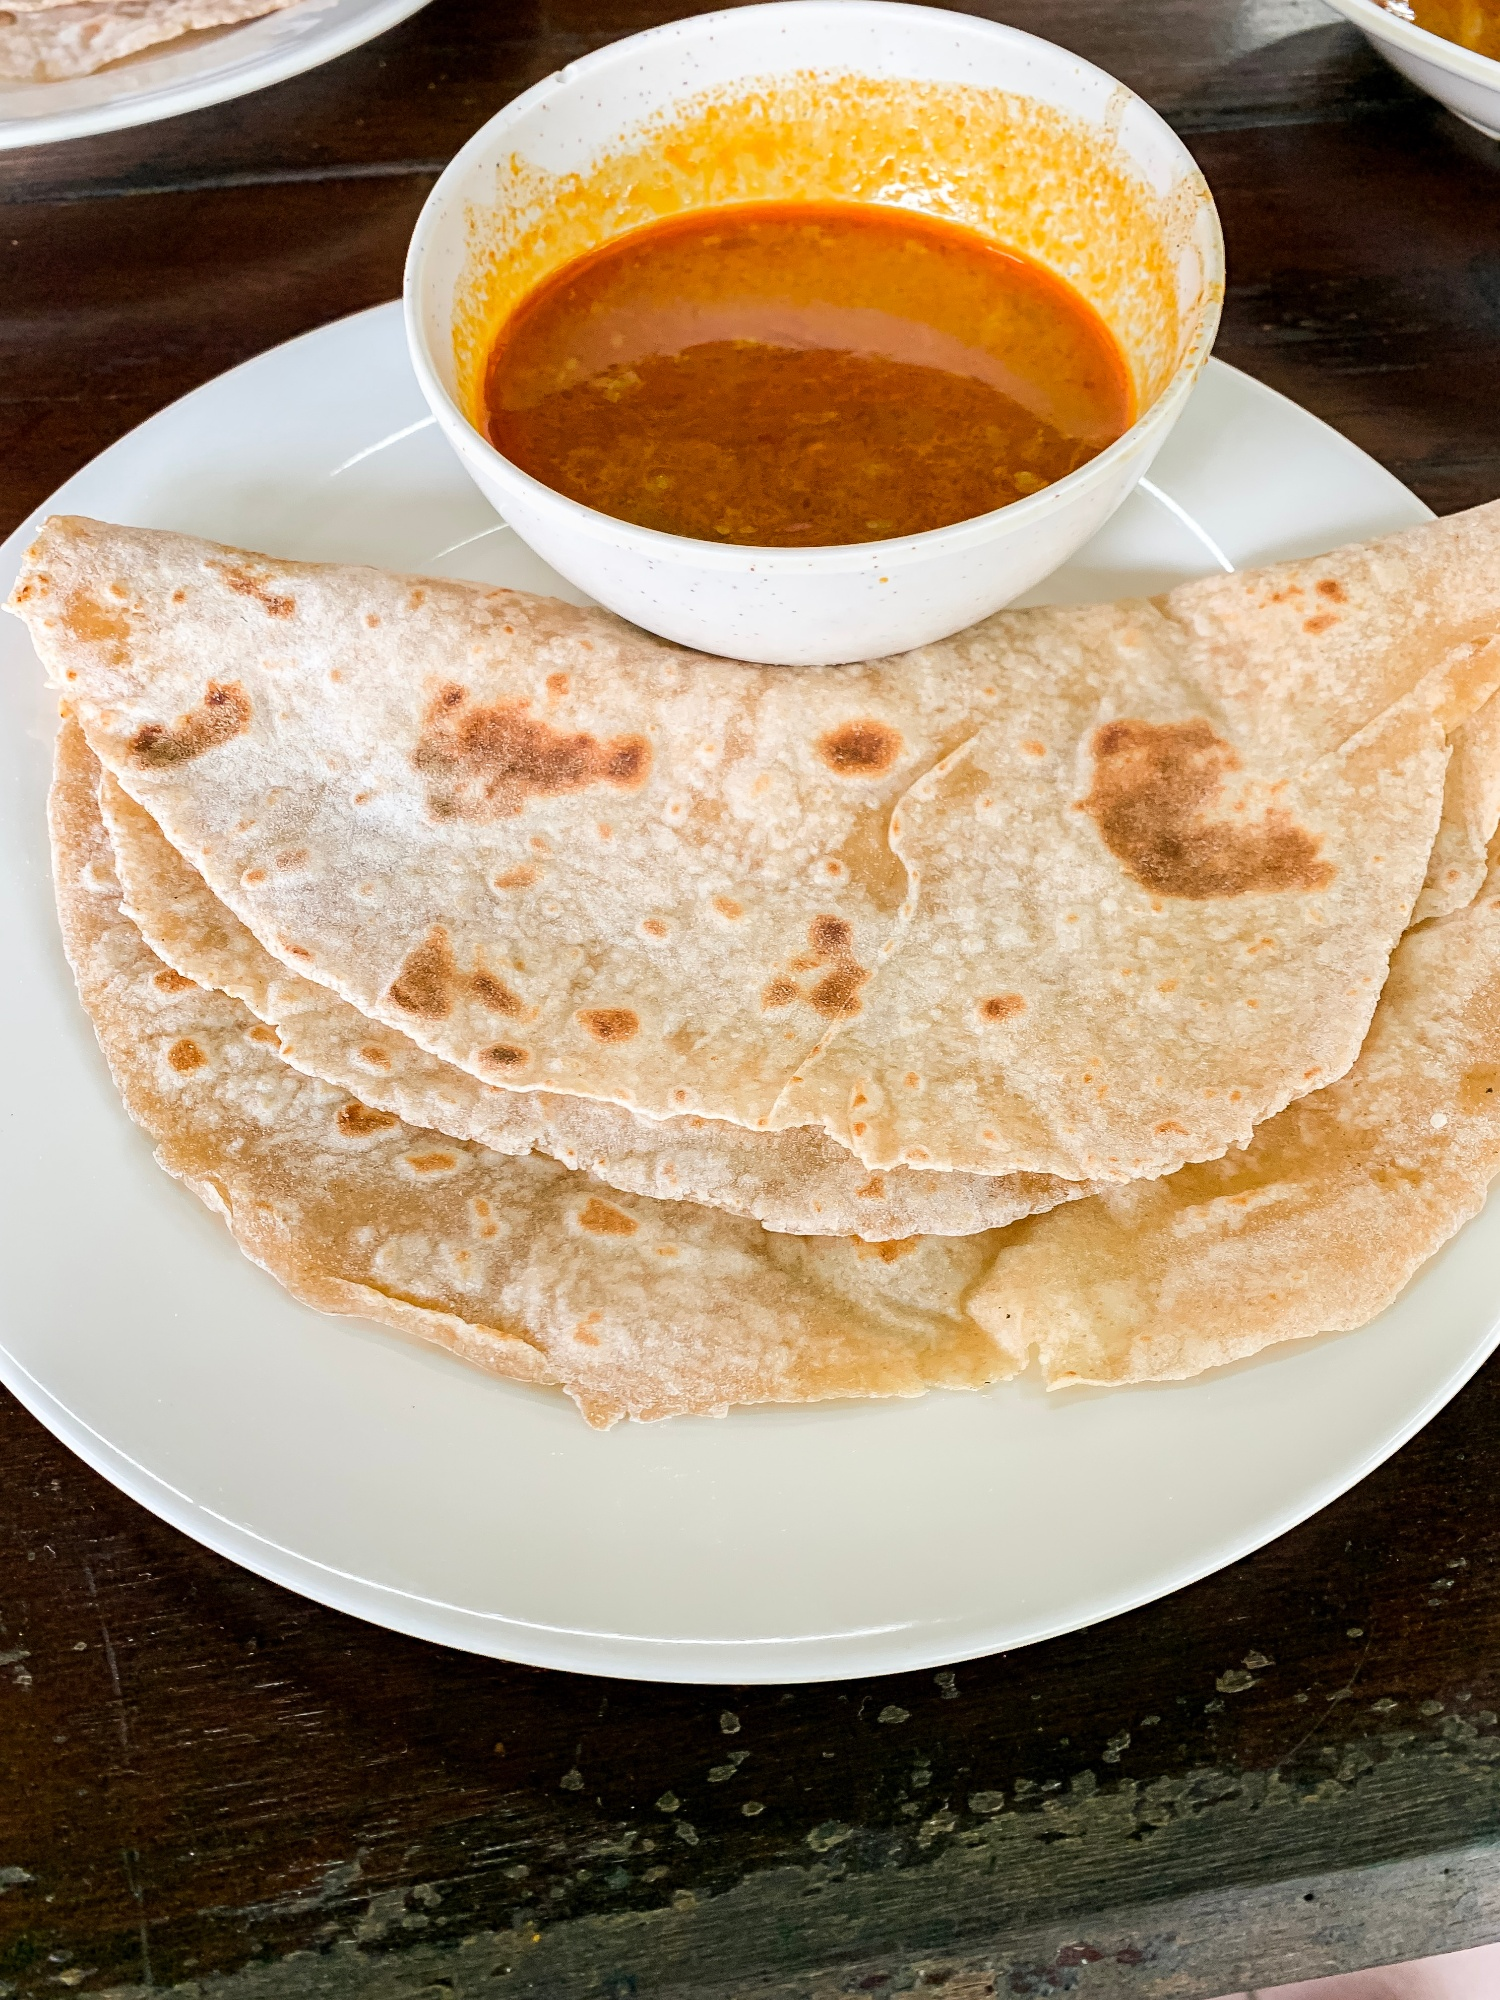Could you tell me more about the cultural significance of this meal? Certainly! The meal depicted in the image, consisting of rotis and curry, is a staple in many Indian households. Roti, also known as chapati, is a type of unleavened bread made primarily from whole wheat flour and is an essential element in Indian cuisine. It is often served with a variety of vegetables, lentils, or meat curries, providing a balanced diet. Culturally, rotis are not just food but a symbol of sustenance and familial unity. They're typically homemade, and the process of preparing them can be a communal activity, bringing family members together. The curry, rich in spices, highlights the intricate spice blends unique to Indian cuisine, reflecting the regional diversity. This combination of roti and curry is versatile and consumed across all social strata, making it a true representation of Indian food culture. Why do you think rotis are such a common choice over other types of bread? Rotis are favored for several reasons, including their simplicity and nutritional value. Unlike white bread, which is made from refined flour, rotis are made from whole wheat, which retains the bran and germ, providing more fiber and nutrients. This makes rotis a healthier option that supports better digestion and provides sustained energy. Their basic ingredients of flour, water, and optional salt make them an economical and accessible staple. The preparation of rotis is also quicker and does not require an oven, making them convenient for daily meals. Moreover, their neutral taste pairs well with various spicy and savory curries, making them a versatile accompaniment in Indian cuisine. 